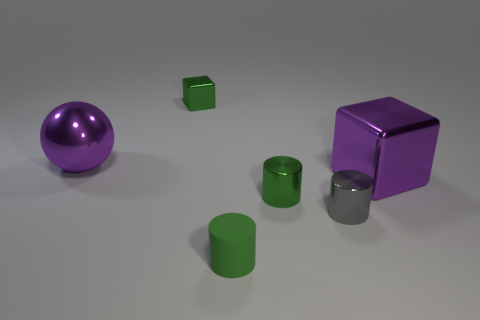There is a small object in front of the metal object in front of the green metal object in front of the purple metal ball; what color is it?
Keep it short and to the point. Green. Is the size of the shiny ball the same as the purple metal object that is to the right of the green cube?
Offer a very short reply. Yes. How many objects are small gray objects or purple shiny balls?
Your answer should be very brief. 2. Is there a green thing that has the same material as the gray thing?
Offer a very short reply. Yes. What size is the block that is the same color as the large metal sphere?
Keep it short and to the point. Large. There is a large metal thing that is right of the small green shiny thing on the left side of the tiny green metallic cylinder; what color is it?
Ensure brevity in your answer.  Purple. Does the gray metallic object have the same size as the rubber object?
Make the answer very short. Yes. How many spheres are either big purple shiny things or gray metal things?
Offer a terse response. 1. What number of tiny gray metallic cylinders are to the left of the purple object that is on the left side of the purple shiny block?
Offer a very short reply. 0. Is the tiny green rubber thing the same shape as the small gray metallic thing?
Provide a succinct answer. Yes. 